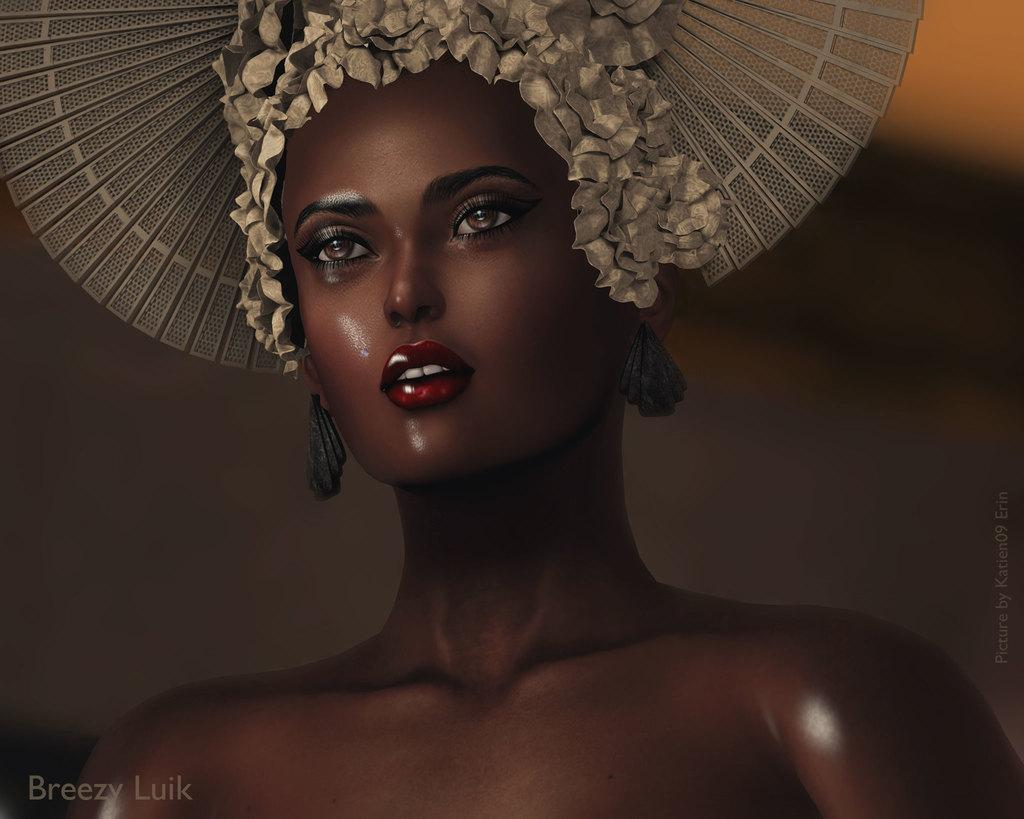What type of image is being described? The image is animated. Can you describe the character in the image? There is a woman in the image. What is the woman wearing on her head? The woman is wearing a hat. How would you describe the background of the image? The background is blurred. Are there any additional features on the image? Yes, there are watermarks on the image. What type of circle can be seen in the image? There is no circle present in the image. 